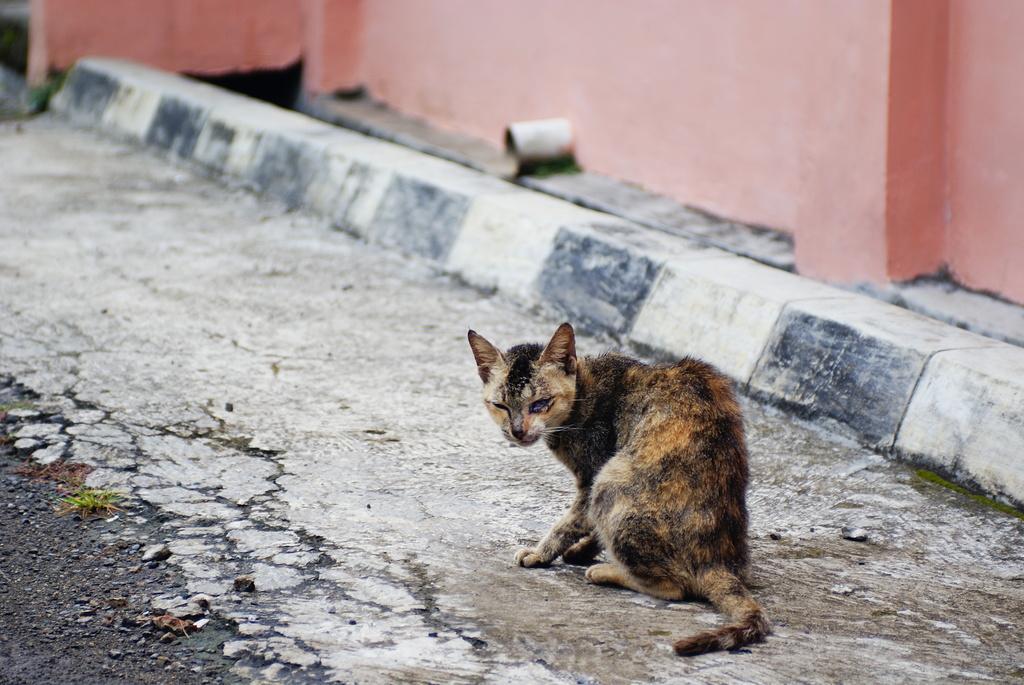How would you summarize this image in a sentence or two? In front of the image there is a cat on the road. In the background of the image there is a wall. 